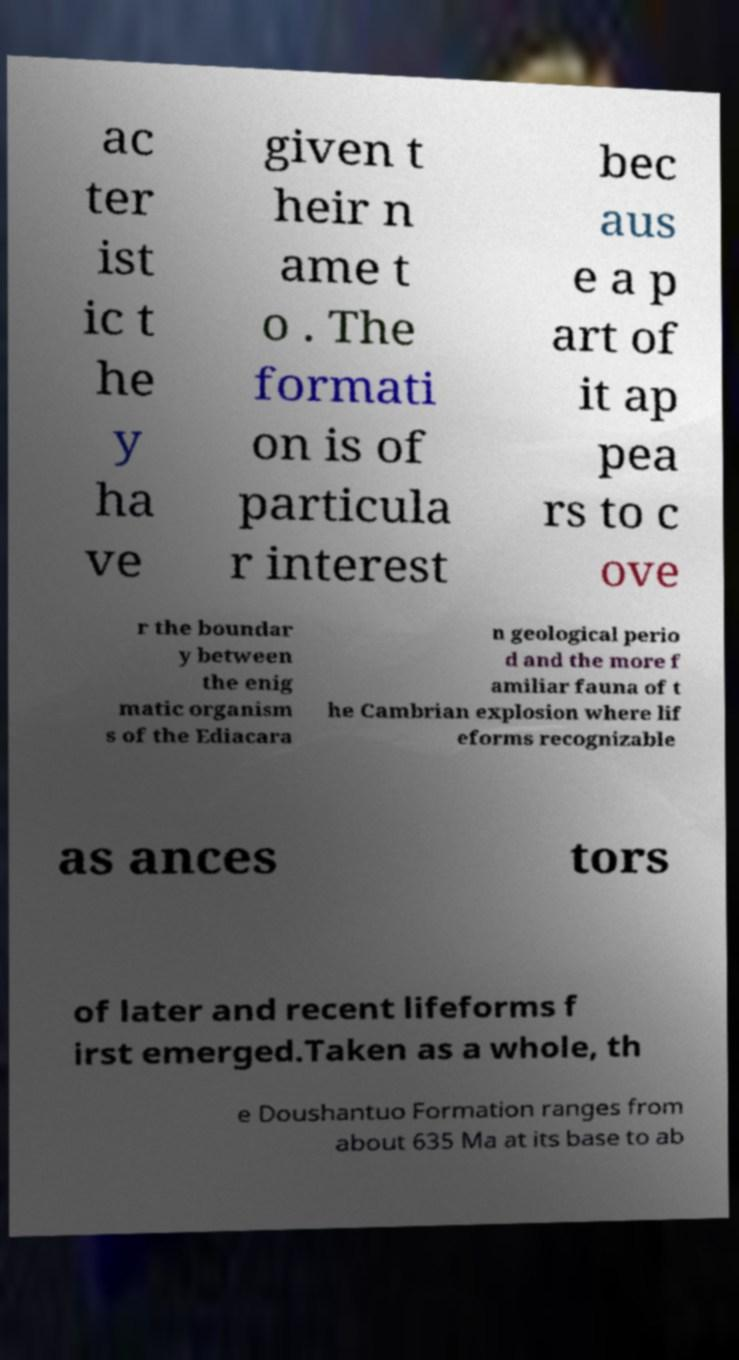Could you extract and type out the text from this image? ac ter ist ic t he y ha ve given t heir n ame t o . The formati on is of particula r interest bec aus e a p art of it ap pea rs to c ove r the boundar y between the enig matic organism s of the Ediacara n geological perio d and the more f amiliar fauna of t he Cambrian explosion where lif eforms recognizable as ances tors of later and recent lifeforms f irst emerged.Taken as a whole, th e Doushantuo Formation ranges from about 635 Ma at its base to ab 